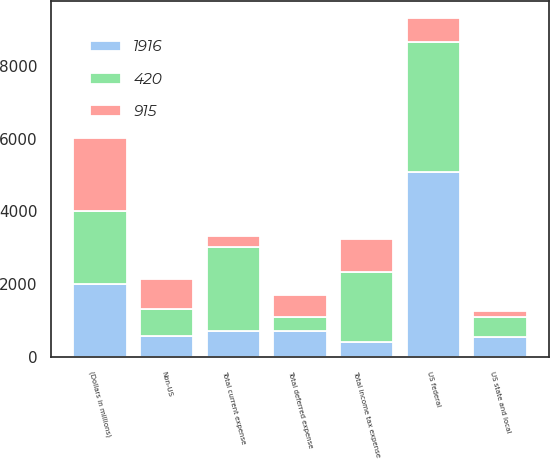<chart> <loc_0><loc_0><loc_500><loc_500><stacked_bar_chart><ecel><fcel>(Dollars in millions)<fcel>US federal<fcel>US state and local<fcel>Non-US<fcel>Total current expense<fcel>Total deferred expense<fcel>Total income tax expense<nl><fcel>915<fcel>2010<fcel>666<fcel>158<fcel>815<fcel>307<fcel>608<fcel>915<nl><fcel>420<fcel>2009<fcel>3576<fcel>555<fcel>735<fcel>2286<fcel>370<fcel>1916<nl><fcel>1916<fcel>2008<fcel>5075<fcel>561<fcel>585<fcel>735<fcel>735<fcel>420<nl></chart> 